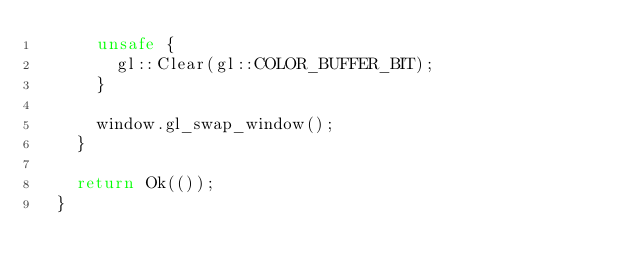<code> <loc_0><loc_0><loc_500><loc_500><_Rust_>      unsafe {
        gl::Clear(gl::COLOR_BUFFER_BIT);
      }
  
      window.gl_swap_window();
    }
  
    return Ok(());
  }</code> 